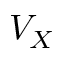<formula> <loc_0><loc_0><loc_500><loc_500>V _ { X }</formula> 